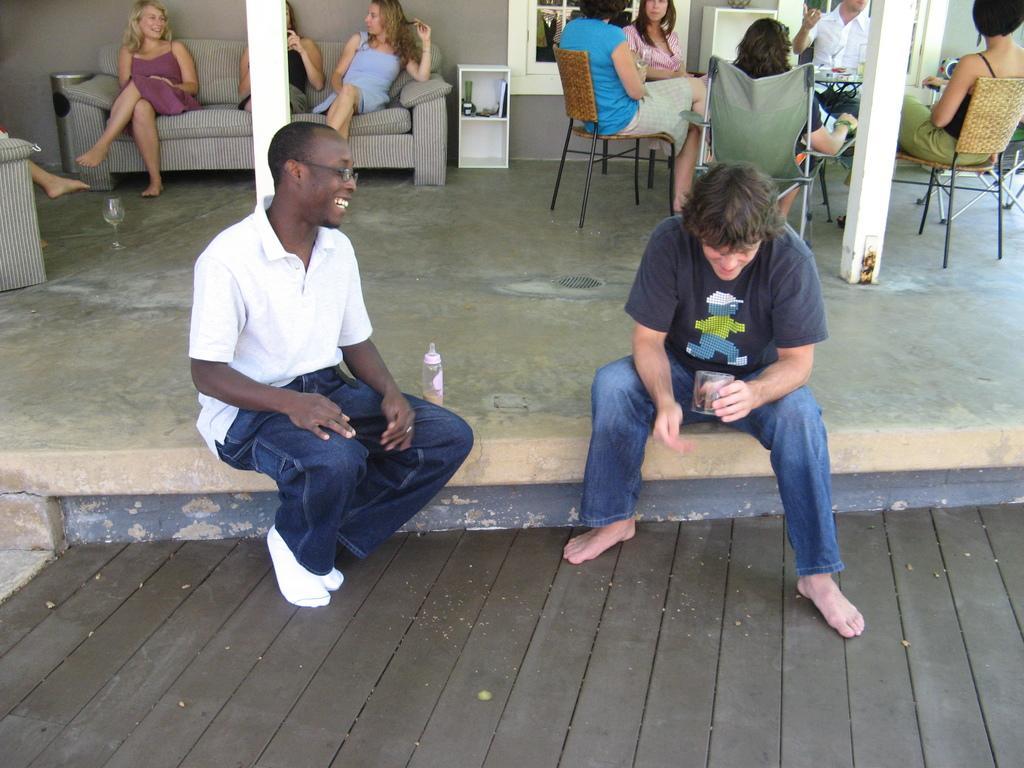Describe this image in one or two sentences. In this picture there are two people sitting on the floor. In the background we also observe few people sitting on the sofas and there are people who are sitting in a round table. 